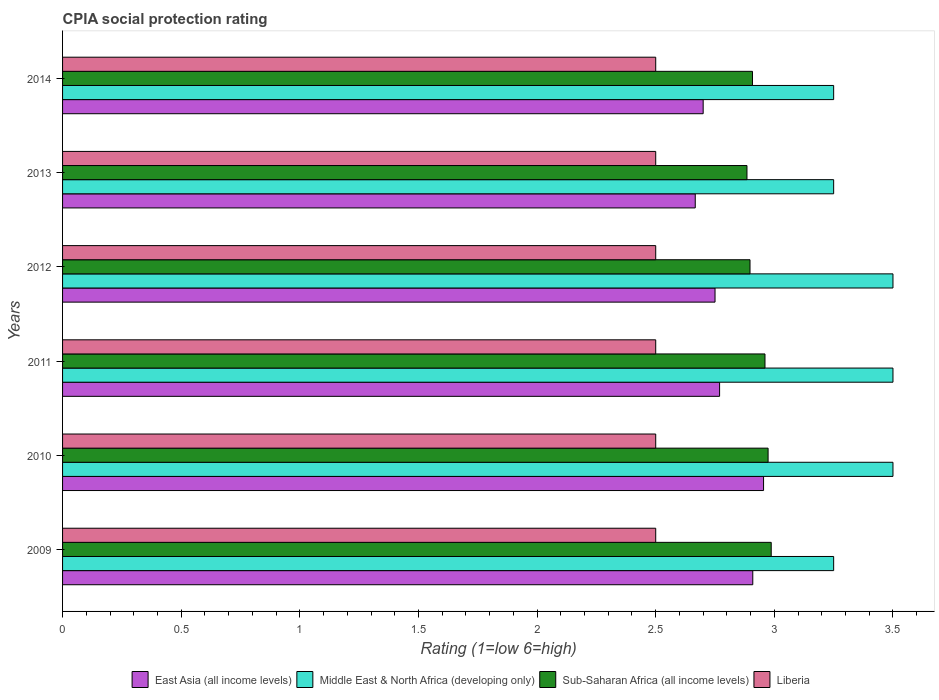How many different coloured bars are there?
Provide a short and direct response. 4. How many groups of bars are there?
Make the answer very short. 6. Are the number of bars on each tick of the Y-axis equal?
Keep it short and to the point. Yes. What is the label of the 1st group of bars from the top?
Offer a terse response. 2014. In how many cases, is the number of bars for a given year not equal to the number of legend labels?
Offer a terse response. 0. What is the CPIA rating in Sub-Saharan Africa (all income levels) in 2013?
Ensure brevity in your answer.  2.88. In which year was the CPIA rating in Middle East & North Africa (developing only) maximum?
Provide a short and direct response. 2010. In which year was the CPIA rating in East Asia (all income levels) minimum?
Your answer should be compact. 2013. What is the total CPIA rating in Sub-Saharan Africa (all income levels) in the graph?
Your response must be concise. 17.61. What is the difference between the CPIA rating in East Asia (all income levels) in 2012 and that in 2013?
Make the answer very short. 0.08. What is the difference between the CPIA rating in Middle East & North Africa (developing only) in 2009 and the CPIA rating in Sub-Saharan Africa (all income levels) in 2013?
Your answer should be very brief. 0.37. What is the average CPIA rating in Sub-Saharan Africa (all income levels) per year?
Provide a short and direct response. 2.94. In the year 2011, what is the difference between the CPIA rating in Liberia and CPIA rating in Sub-Saharan Africa (all income levels)?
Keep it short and to the point. -0.46. In how many years, is the CPIA rating in Liberia greater than 0.8 ?
Make the answer very short. 6. What is the ratio of the CPIA rating in East Asia (all income levels) in 2013 to that in 2014?
Provide a short and direct response. 0.99. What is the difference between the highest and the second highest CPIA rating in Sub-Saharan Africa (all income levels)?
Ensure brevity in your answer.  0.01. What is the difference between the highest and the lowest CPIA rating in East Asia (all income levels)?
Your answer should be compact. 0.29. In how many years, is the CPIA rating in Middle East & North Africa (developing only) greater than the average CPIA rating in Middle East & North Africa (developing only) taken over all years?
Offer a terse response. 3. Is the sum of the CPIA rating in Middle East & North Africa (developing only) in 2010 and 2011 greater than the maximum CPIA rating in East Asia (all income levels) across all years?
Your answer should be compact. Yes. What does the 2nd bar from the top in 2014 represents?
Your response must be concise. Sub-Saharan Africa (all income levels). What does the 1st bar from the bottom in 2012 represents?
Offer a terse response. East Asia (all income levels). Is it the case that in every year, the sum of the CPIA rating in Sub-Saharan Africa (all income levels) and CPIA rating in East Asia (all income levels) is greater than the CPIA rating in Liberia?
Offer a terse response. Yes. How many bars are there?
Keep it short and to the point. 24. How many years are there in the graph?
Keep it short and to the point. 6. What is the difference between two consecutive major ticks on the X-axis?
Give a very brief answer. 0.5. Does the graph contain any zero values?
Offer a terse response. No. Does the graph contain grids?
Keep it short and to the point. No. Where does the legend appear in the graph?
Your answer should be very brief. Bottom center. What is the title of the graph?
Provide a short and direct response. CPIA social protection rating. What is the label or title of the X-axis?
Provide a succinct answer. Rating (1=low 6=high). What is the label or title of the Y-axis?
Provide a short and direct response. Years. What is the Rating (1=low 6=high) in East Asia (all income levels) in 2009?
Your answer should be compact. 2.91. What is the Rating (1=low 6=high) of Middle East & North Africa (developing only) in 2009?
Offer a terse response. 3.25. What is the Rating (1=low 6=high) of Sub-Saharan Africa (all income levels) in 2009?
Give a very brief answer. 2.99. What is the Rating (1=low 6=high) in East Asia (all income levels) in 2010?
Ensure brevity in your answer.  2.95. What is the Rating (1=low 6=high) of Sub-Saharan Africa (all income levels) in 2010?
Provide a short and direct response. 2.97. What is the Rating (1=low 6=high) of East Asia (all income levels) in 2011?
Offer a very short reply. 2.77. What is the Rating (1=low 6=high) in Sub-Saharan Africa (all income levels) in 2011?
Keep it short and to the point. 2.96. What is the Rating (1=low 6=high) of East Asia (all income levels) in 2012?
Provide a succinct answer. 2.75. What is the Rating (1=low 6=high) in Middle East & North Africa (developing only) in 2012?
Your answer should be compact. 3.5. What is the Rating (1=low 6=high) in Sub-Saharan Africa (all income levels) in 2012?
Provide a succinct answer. 2.9. What is the Rating (1=low 6=high) of Liberia in 2012?
Offer a terse response. 2.5. What is the Rating (1=low 6=high) of East Asia (all income levels) in 2013?
Provide a succinct answer. 2.67. What is the Rating (1=low 6=high) of Sub-Saharan Africa (all income levels) in 2013?
Ensure brevity in your answer.  2.88. What is the Rating (1=low 6=high) in Sub-Saharan Africa (all income levels) in 2014?
Make the answer very short. 2.91. What is the Rating (1=low 6=high) of Liberia in 2014?
Offer a very short reply. 2.5. Across all years, what is the maximum Rating (1=low 6=high) of East Asia (all income levels)?
Ensure brevity in your answer.  2.95. Across all years, what is the maximum Rating (1=low 6=high) of Middle East & North Africa (developing only)?
Give a very brief answer. 3.5. Across all years, what is the maximum Rating (1=low 6=high) in Sub-Saharan Africa (all income levels)?
Offer a terse response. 2.99. Across all years, what is the maximum Rating (1=low 6=high) of Liberia?
Provide a short and direct response. 2.5. Across all years, what is the minimum Rating (1=low 6=high) of East Asia (all income levels)?
Provide a short and direct response. 2.67. Across all years, what is the minimum Rating (1=low 6=high) of Sub-Saharan Africa (all income levels)?
Your answer should be compact. 2.88. Across all years, what is the minimum Rating (1=low 6=high) of Liberia?
Provide a short and direct response. 2.5. What is the total Rating (1=low 6=high) of East Asia (all income levels) in the graph?
Your answer should be very brief. 16.75. What is the total Rating (1=low 6=high) of Middle East & North Africa (developing only) in the graph?
Give a very brief answer. 20.25. What is the total Rating (1=low 6=high) in Sub-Saharan Africa (all income levels) in the graph?
Your answer should be very brief. 17.61. What is the total Rating (1=low 6=high) in Liberia in the graph?
Offer a terse response. 15. What is the difference between the Rating (1=low 6=high) in East Asia (all income levels) in 2009 and that in 2010?
Make the answer very short. -0.05. What is the difference between the Rating (1=low 6=high) in Middle East & North Africa (developing only) in 2009 and that in 2010?
Provide a succinct answer. -0.25. What is the difference between the Rating (1=low 6=high) of Sub-Saharan Africa (all income levels) in 2009 and that in 2010?
Provide a succinct answer. 0.01. What is the difference between the Rating (1=low 6=high) in Liberia in 2009 and that in 2010?
Keep it short and to the point. 0. What is the difference between the Rating (1=low 6=high) in East Asia (all income levels) in 2009 and that in 2011?
Offer a terse response. 0.14. What is the difference between the Rating (1=low 6=high) of Middle East & North Africa (developing only) in 2009 and that in 2011?
Your answer should be compact. -0.25. What is the difference between the Rating (1=low 6=high) of Sub-Saharan Africa (all income levels) in 2009 and that in 2011?
Provide a short and direct response. 0.03. What is the difference between the Rating (1=low 6=high) of Liberia in 2009 and that in 2011?
Give a very brief answer. 0. What is the difference between the Rating (1=low 6=high) of East Asia (all income levels) in 2009 and that in 2012?
Provide a short and direct response. 0.16. What is the difference between the Rating (1=low 6=high) in Middle East & North Africa (developing only) in 2009 and that in 2012?
Keep it short and to the point. -0.25. What is the difference between the Rating (1=low 6=high) in Sub-Saharan Africa (all income levels) in 2009 and that in 2012?
Keep it short and to the point. 0.09. What is the difference between the Rating (1=low 6=high) in East Asia (all income levels) in 2009 and that in 2013?
Keep it short and to the point. 0.24. What is the difference between the Rating (1=low 6=high) of Sub-Saharan Africa (all income levels) in 2009 and that in 2013?
Offer a very short reply. 0.1. What is the difference between the Rating (1=low 6=high) of Liberia in 2009 and that in 2013?
Provide a succinct answer. 0. What is the difference between the Rating (1=low 6=high) of East Asia (all income levels) in 2009 and that in 2014?
Provide a short and direct response. 0.21. What is the difference between the Rating (1=low 6=high) of Sub-Saharan Africa (all income levels) in 2009 and that in 2014?
Your answer should be very brief. 0.08. What is the difference between the Rating (1=low 6=high) of East Asia (all income levels) in 2010 and that in 2011?
Your answer should be very brief. 0.19. What is the difference between the Rating (1=low 6=high) of Middle East & North Africa (developing only) in 2010 and that in 2011?
Ensure brevity in your answer.  0. What is the difference between the Rating (1=low 6=high) of Sub-Saharan Africa (all income levels) in 2010 and that in 2011?
Give a very brief answer. 0.01. What is the difference between the Rating (1=low 6=high) of East Asia (all income levels) in 2010 and that in 2012?
Make the answer very short. 0.2. What is the difference between the Rating (1=low 6=high) of Middle East & North Africa (developing only) in 2010 and that in 2012?
Keep it short and to the point. 0. What is the difference between the Rating (1=low 6=high) in Sub-Saharan Africa (all income levels) in 2010 and that in 2012?
Keep it short and to the point. 0.08. What is the difference between the Rating (1=low 6=high) of East Asia (all income levels) in 2010 and that in 2013?
Give a very brief answer. 0.29. What is the difference between the Rating (1=low 6=high) of Sub-Saharan Africa (all income levels) in 2010 and that in 2013?
Your answer should be compact. 0.09. What is the difference between the Rating (1=low 6=high) of East Asia (all income levels) in 2010 and that in 2014?
Offer a terse response. 0.25. What is the difference between the Rating (1=low 6=high) of Middle East & North Africa (developing only) in 2010 and that in 2014?
Your answer should be very brief. 0.25. What is the difference between the Rating (1=low 6=high) of Sub-Saharan Africa (all income levels) in 2010 and that in 2014?
Make the answer very short. 0.07. What is the difference between the Rating (1=low 6=high) of Liberia in 2010 and that in 2014?
Provide a succinct answer. 0. What is the difference between the Rating (1=low 6=high) of East Asia (all income levels) in 2011 and that in 2012?
Your answer should be compact. 0.02. What is the difference between the Rating (1=low 6=high) of Sub-Saharan Africa (all income levels) in 2011 and that in 2012?
Keep it short and to the point. 0.06. What is the difference between the Rating (1=low 6=high) of Liberia in 2011 and that in 2012?
Your answer should be very brief. 0. What is the difference between the Rating (1=low 6=high) of East Asia (all income levels) in 2011 and that in 2013?
Your response must be concise. 0.1. What is the difference between the Rating (1=low 6=high) of Middle East & North Africa (developing only) in 2011 and that in 2013?
Make the answer very short. 0.25. What is the difference between the Rating (1=low 6=high) of Sub-Saharan Africa (all income levels) in 2011 and that in 2013?
Ensure brevity in your answer.  0.08. What is the difference between the Rating (1=low 6=high) in Liberia in 2011 and that in 2013?
Offer a very short reply. 0. What is the difference between the Rating (1=low 6=high) in East Asia (all income levels) in 2011 and that in 2014?
Offer a terse response. 0.07. What is the difference between the Rating (1=low 6=high) in Middle East & North Africa (developing only) in 2011 and that in 2014?
Keep it short and to the point. 0.25. What is the difference between the Rating (1=low 6=high) of Sub-Saharan Africa (all income levels) in 2011 and that in 2014?
Offer a very short reply. 0.05. What is the difference between the Rating (1=low 6=high) of East Asia (all income levels) in 2012 and that in 2013?
Provide a succinct answer. 0.08. What is the difference between the Rating (1=low 6=high) in Middle East & North Africa (developing only) in 2012 and that in 2013?
Your response must be concise. 0.25. What is the difference between the Rating (1=low 6=high) in Sub-Saharan Africa (all income levels) in 2012 and that in 2013?
Offer a very short reply. 0.01. What is the difference between the Rating (1=low 6=high) in Liberia in 2012 and that in 2013?
Your answer should be very brief. 0. What is the difference between the Rating (1=low 6=high) in Sub-Saharan Africa (all income levels) in 2012 and that in 2014?
Offer a very short reply. -0.01. What is the difference between the Rating (1=low 6=high) in Liberia in 2012 and that in 2014?
Give a very brief answer. 0. What is the difference between the Rating (1=low 6=high) of East Asia (all income levels) in 2013 and that in 2014?
Your response must be concise. -0.03. What is the difference between the Rating (1=low 6=high) of Middle East & North Africa (developing only) in 2013 and that in 2014?
Give a very brief answer. 0. What is the difference between the Rating (1=low 6=high) in Sub-Saharan Africa (all income levels) in 2013 and that in 2014?
Provide a short and direct response. -0.02. What is the difference between the Rating (1=low 6=high) in Liberia in 2013 and that in 2014?
Your response must be concise. 0. What is the difference between the Rating (1=low 6=high) in East Asia (all income levels) in 2009 and the Rating (1=low 6=high) in Middle East & North Africa (developing only) in 2010?
Your answer should be compact. -0.59. What is the difference between the Rating (1=low 6=high) in East Asia (all income levels) in 2009 and the Rating (1=low 6=high) in Sub-Saharan Africa (all income levels) in 2010?
Provide a short and direct response. -0.06. What is the difference between the Rating (1=low 6=high) of East Asia (all income levels) in 2009 and the Rating (1=low 6=high) of Liberia in 2010?
Your answer should be very brief. 0.41. What is the difference between the Rating (1=low 6=high) of Middle East & North Africa (developing only) in 2009 and the Rating (1=low 6=high) of Sub-Saharan Africa (all income levels) in 2010?
Your answer should be compact. 0.28. What is the difference between the Rating (1=low 6=high) in Middle East & North Africa (developing only) in 2009 and the Rating (1=low 6=high) in Liberia in 2010?
Keep it short and to the point. 0.75. What is the difference between the Rating (1=low 6=high) in Sub-Saharan Africa (all income levels) in 2009 and the Rating (1=low 6=high) in Liberia in 2010?
Your answer should be compact. 0.49. What is the difference between the Rating (1=low 6=high) in East Asia (all income levels) in 2009 and the Rating (1=low 6=high) in Middle East & North Africa (developing only) in 2011?
Provide a succinct answer. -0.59. What is the difference between the Rating (1=low 6=high) in East Asia (all income levels) in 2009 and the Rating (1=low 6=high) in Sub-Saharan Africa (all income levels) in 2011?
Ensure brevity in your answer.  -0.05. What is the difference between the Rating (1=low 6=high) of East Asia (all income levels) in 2009 and the Rating (1=low 6=high) of Liberia in 2011?
Give a very brief answer. 0.41. What is the difference between the Rating (1=low 6=high) of Middle East & North Africa (developing only) in 2009 and the Rating (1=low 6=high) of Sub-Saharan Africa (all income levels) in 2011?
Offer a terse response. 0.29. What is the difference between the Rating (1=low 6=high) in Middle East & North Africa (developing only) in 2009 and the Rating (1=low 6=high) in Liberia in 2011?
Provide a short and direct response. 0.75. What is the difference between the Rating (1=low 6=high) in Sub-Saharan Africa (all income levels) in 2009 and the Rating (1=low 6=high) in Liberia in 2011?
Ensure brevity in your answer.  0.49. What is the difference between the Rating (1=low 6=high) in East Asia (all income levels) in 2009 and the Rating (1=low 6=high) in Middle East & North Africa (developing only) in 2012?
Provide a short and direct response. -0.59. What is the difference between the Rating (1=low 6=high) of East Asia (all income levels) in 2009 and the Rating (1=low 6=high) of Sub-Saharan Africa (all income levels) in 2012?
Make the answer very short. 0.01. What is the difference between the Rating (1=low 6=high) of East Asia (all income levels) in 2009 and the Rating (1=low 6=high) of Liberia in 2012?
Make the answer very short. 0.41. What is the difference between the Rating (1=low 6=high) of Middle East & North Africa (developing only) in 2009 and the Rating (1=low 6=high) of Sub-Saharan Africa (all income levels) in 2012?
Give a very brief answer. 0.35. What is the difference between the Rating (1=low 6=high) in Middle East & North Africa (developing only) in 2009 and the Rating (1=low 6=high) in Liberia in 2012?
Provide a short and direct response. 0.75. What is the difference between the Rating (1=low 6=high) in Sub-Saharan Africa (all income levels) in 2009 and the Rating (1=low 6=high) in Liberia in 2012?
Make the answer very short. 0.49. What is the difference between the Rating (1=low 6=high) in East Asia (all income levels) in 2009 and the Rating (1=low 6=high) in Middle East & North Africa (developing only) in 2013?
Offer a terse response. -0.34. What is the difference between the Rating (1=low 6=high) in East Asia (all income levels) in 2009 and the Rating (1=low 6=high) in Sub-Saharan Africa (all income levels) in 2013?
Ensure brevity in your answer.  0.02. What is the difference between the Rating (1=low 6=high) in East Asia (all income levels) in 2009 and the Rating (1=low 6=high) in Liberia in 2013?
Provide a succinct answer. 0.41. What is the difference between the Rating (1=low 6=high) of Middle East & North Africa (developing only) in 2009 and the Rating (1=low 6=high) of Sub-Saharan Africa (all income levels) in 2013?
Offer a very short reply. 0.37. What is the difference between the Rating (1=low 6=high) of Middle East & North Africa (developing only) in 2009 and the Rating (1=low 6=high) of Liberia in 2013?
Keep it short and to the point. 0.75. What is the difference between the Rating (1=low 6=high) in Sub-Saharan Africa (all income levels) in 2009 and the Rating (1=low 6=high) in Liberia in 2013?
Ensure brevity in your answer.  0.49. What is the difference between the Rating (1=low 6=high) in East Asia (all income levels) in 2009 and the Rating (1=low 6=high) in Middle East & North Africa (developing only) in 2014?
Offer a terse response. -0.34. What is the difference between the Rating (1=low 6=high) in East Asia (all income levels) in 2009 and the Rating (1=low 6=high) in Sub-Saharan Africa (all income levels) in 2014?
Offer a very short reply. 0. What is the difference between the Rating (1=low 6=high) of East Asia (all income levels) in 2009 and the Rating (1=low 6=high) of Liberia in 2014?
Provide a succinct answer. 0.41. What is the difference between the Rating (1=low 6=high) of Middle East & North Africa (developing only) in 2009 and the Rating (1=low 6=high) of Sub-Saharan Africa (all income levels) in 2014?
Your answer should be very brief. 0.34. What is the difference between the Rating (1=low 6=high) of Sub-Saharan Africa (all income levels) in 2009 and the Rating (1=low 6=high) of Liberia in 2014?
Keep it short and to the point. 0.49. What is the difference between the Rating (1=low 6=high) of East Asia (all income levels) in 2010 and the Rating (1=low 6=high) of Middle East & North Africa (developing only) in 2011?
Give a very brief answer. -0.55. What is the difference between the Rating (1=low 6=high) in East Asia (all income levels) in 2010 and the Rating (1=low 6=high) in Sub-Saharan Africa (all income levels) in 2011?
Make the answer very short. -0.01. What is the difference between the Rating (1=low 6=high) of East Asia (all income levels) in 2010 and the Rating (1=low 6=high) of Liberia in 2011?
Provide a short and direct response. 0.45. What is the difference between the Rating (1=low 6=high) of Middle East & North Africa (developing only) in 2010 and the Rating (1=low 6=high) of Sub-Saharan Africa (all income levels) in 2011?
Keep it short and to the point. 0.54. What is the difference between the Rating (1=low 6=high) in Middle East & North Africa (developing only) in 2010 and the Rating (1=low 6=high) in Liberia in 2011?
Ensure brevity in your answer.  1. What is the difference between the Rating (1=low 6=high) in Sub-Saharan Africa (all income levels) in 2010 and the Rating (1=low 6=high) in Liberia in 2011?
Keep it short and to the point. 0.47. What is the difference between the Rating (1=low 6=high) in East Asia (all income levels) in 2010 and the Rating (1=low 6=high) in Middle East & North Africa (developing only) in 2012?
Keep it short and to the point. -0.55. What is the difference between the Rating (1=low 6=high) in East Asia (all income levels) in 2010 and the Rating (1=low 6=high) in Sub-Saharan Africa (all income levels) in 2012?
Your answer should be compact. 0.06. What is the difference between the Rating (1=low 6=high) of East Asia (all income levels) in 2010 and the Rating (1=low 6=high) of Liberia in 2012?
Provide a succinct answer. 0.45. What is the difference between the Rating (1=low 6=high) in Middle East & North Africa (developing only) in 2010 and the Rating (1=low 6=high) in Sub-Saharan Africa (all income levels) in 2012?
Your response must be concise. 0.6. What is the difference between the Rating (1=low 6=high) in Sub-Saharan Africa (all income levels) in 2010 and the Rating (1=low 6=high) in Liberia in 2012?
Offer a terse response. 0.47. What is the difference between the Rating (1=low 6=high) in East Asia (all income levels) in 2010 and the Rating (1=low 6=high) in Middle East & North Africa (developing only) in 2013?
Keep it short and to the point. -0.3. What is the difference between the Rating (1=low 6=high) of East Asia (all income levels) in 2010 and the Rating (1=low 6=high) of Sub-Saharan Africa (all income levels) in 2013?
Your answer should be compact. 0.07. What is the difference between the Rating (1=low 6=high) of East Asia (all income levels) in 2010 and the Rating (1=low 6=high) of Liberia in 2013?
Offer a terse response. 0.45. What is the difference between the Rating (1=low 6=high) in Middle East & North Africa (developing only) in 2010 and the Rating (1=low 6=high) in Sub-Saharan Africa (all income levels) in 2013?
Keep it short and to the point. 0.62. What is the difference between the Rating (1=low 6=high) in Middle East & North Africa (developing only) in 2010 and the Rating (1=low 6=high) in Liberia in 2013?
Provide a short and direct response. 1. What is the difference between the Rating (1=low 6=high) of Sub-Saharan Africa (all income levels) in 2010 and the Rating (1=low 6=high) of Liberia in 2013?
Offer a very short reply. 0.47. What is the difference between the Rating (1=low 6=high) in East Asia (all income levels) in 2010 and the Rating (1=low 6=high) in Middle East & North Africa (developing only) in 2014?
Offer a very short reply. -0.3. What is the difference between the Rating (1=low 6=high) in East Asia (all income levels) in 2010 and the Rating (1=low 6=high) in Sub-Saharan Africa (all income levels) in 2014?
Offer a terse response. 0.05. What is the difference between the Rating (1=low 6=high) in East Asia (all income levels) in 2010 and the Rating (1=low 6=high) in Liberia in 2014?
Offer a terse response. 0.45. What is the difference between the Rating (1=low 6=high) in Middle East & North Africa (developing only) in 2010 and the Rating (1=low 6=high) in Sub-Saharan Africa (all income levels) in 2014?
Make the answer very short. 0.59. What is the difference between the Rating (1=low 6=high) in Middle East & North Africa (developing only) in 2010 and the Rating (1=low 6=high) in Liberia in 2014?
Your answer should be very brief. 1. What is the difference between the Rating (1=low 6=high) in Sub-Saharan Africa (all income levels) in 2010 and the Rating (1=low 6=high) in Liberia in 2014?
Your response must be concise. 0.47. What is the difference between the Rating (1=low 6=high) in East Asia (all income levels) in 2011 and the Rating (1=low 6=high) in Middle East & North Africa (developing only) in 2012?
Ensure brevity in your answer.  -0.73. What is the difference between the Rating (1=low 6=high) in East Asia (all income levels) in 2011 and the Rating (1=low 6=high) in Sub-Saharan Africa (all income levels) in 2012?
Provide a short and direct response. -0.13. What is the difference between the Rating (1=low 6=high) of East Asia (all income levels) in 2011 and the Rating (1=low 6=high) of Liberia in 2012?
Your answer should be compact. 0.27. What is the difference between the Rating (1=low 6=high) in Middle East & North Africa (developing only) in 2011 and the Rating (1=low 6=high) in Sub-Saharan Africa (all income levels) in 2012?
Ensure brevity in your answer.  0.6. What is the difference between the Rating (1=low 6=high) in Middle East & North Africa (developing only) in 2011 and the Rating (1=low 6=high) in Liberia in 2012?
Your answer should be very brief. 1. What is the difference between the Rating (1=low 6=high) of Sub-Saharan Africa (all income levels) in 2011 and the Rating (1=low 6=high) of Liberia in 2012?
Ensure brevity in your answer.  0.46. What is the difference between the Rating (1=low 6=high) in East Asia (all income levels) in 2011 and the Rating (1=low 6=high) in Middle East & North Africa (developing only) in 2013?
Provide a short and direct response. -0.48. What is the difference between the Rating (1=low 6=high) of East Asia (all income levels) in 2011 and the Rating (1=low 6=high) of Sub-Saharan Africa (all income levels) in 2013?
Your answer should be compact. -0.12. What is the difference between the Rating (1=low 6=high) of East Asia (all income levels) in 2011 and the Rating (1=low 6=high) of Liberia in 2013?
Provide a succinct answer. 0.27. What is the difference between the Rating (1=low 6=high) in Middle East & North Africa (developing only) in 2011 and the Rating (1=low 6=high) in Sub-Saharan Africa (all income levels) in 2013?
Your answer should be compact. 0.62. What is the difference between the Rating (1=low 6=high) of Sub-Saharan Africa (all income levels) in 2011 and the Rating (1=low 6=high) of Liberia in 2013?
Offer a terse response. 0.46. What is the difference between the Rating (1=low 6=high) in East Asia (all income levels) in 2011 and the Rating (1=low 6=high) in Middle East & North Africa (developing only) in 2014?
Offer a very short reply. -0.48. What is the difference between the Rating (1=low 6=high) of East Asia (all income levels) in 2011 and the Rating (1=low 6=high) of Sub-Saharan Africa (all income levels) in 2014?
Your response must be concise. -0.14. What is the difference between the Rating (1=low 6=high) of East Asia (all income levels) in 2011 and the Rating (1=low 6=high) of Liberia in 2014?
Provide a succinct answer. 0.27. What is the difference between the Rating (1=low 6=high) in Middle East & North Africa (developing only) in 2011 and the Rating (1=low 6=high) in Sub-Saharan Africa (all income levels) in 2014?
Your response must be concise. 0.59. What is the difference between the Rating (1=low 6=high) of Sub-Saharan Africa (all income levels) in 2011 and the Rating (1=low 6=high) of Liberia in 2014?
Your response must be concise. 0.46. What is the difference between the Rating (1=low 6=high) of East Asia (all income levels) in 2012 and the Rating (1=low 6=high) of Sub-Saharan Africa (all income levels) in 2013?
Ensure brevity in your answer.  -0.13. What is the difference between the Rating (1=low 6=high) in East Asia (all income levels) in 2012 and the Rating (1=low 6=high) in Liberia in 2013?
Keep it short and to the point. 0.25. What is the difference between the Rating (1=low 6=high) in Middle East & North Africa (developing only) in 2012 and the Rating (1=low 6=high) in Sub-Saharan Africa (all income levels) in 2013?
Provide a succinct answer. 0.62. What is the difference between the Rating (1=low 6=high) of Middle East & North Africa (developing only) in 2012 and the Rating (1=low 6=high) of Liberia in 2013?
Provide a succinct answer. 1. What is the difference between the Rating (1=low 6=high) in Sub-Saharan Africa (all income levels) in 2012 and the Rating (1=low 6=high) in Liberia in 2013?
Provide a succinct answer. 0.4. What is the difference between the Rating (1=low 6=high) of East Asia (all income levels) in 2012 and the Rating (1=low 6=high) of Sub-Saharan Africa (all income levels) in 2014?
Make the answer very short. -0.16. What is the difference between the Rating (1=low 6=high) of East Asia (all income levels) in 2012 and the Rating (1=low 6=high) of Liberia in 2014?
Keep it short and to the point. 0.25. What is the difference between the Rating (1=low 6=high) of Middle East & North Africa (developing only) in 2012 and the Rating (1=low 6=high) of Sub-Saharan Africa (all income levels) in 2014?
Your answer should be compact. 0.59. What is the difference between the Rating (1=low 6=high) of Sub-Saharan Africa (all income levels) in 2012 and the Rating (1=low 6=high) of Liberia in 2014?
Your response must be concise. 0.4. What is the difference between the Rating (1=low 6=high) of East Asia (all income levels) in 2013 and the Rating (1=low 6=high) of Middle East & North Africa (developing only) in 2014?
Offer a very short reply. -0.58. What is the difference between the Rating (1=low 6=high) of East Asia (all income levels) in 2013 and the Rating (1=low 6=high) of Sub-Saharan Africa (all income levels) in 2014?
Ensure brevity in your answer.  -0.24. What is the difference between the Rating (1=low 6=high) in Middle East & North Africa (developing only) in 2013 and the Rating (1=low 6=high) in Sub-Saharan Africa (all income levels) in 2014?
Keep it short and to the point. 0.34. What is the difference between the Rating (1=low 6=high) in Middle East & North Africa (developing only) in 2013 and the Rating (1=low 6=high) in Liberia in 2014?
Offer a very short reply. 0.75. What is the difference between the Rating (1=low 6=high) of Sub-Saharan Africa (all income levels) in 2013 and the Rating (1=low 6=high) of Liberia in 2014?
Provide a short and direct response. 0.38. What is the average Rating (1=low 6=high) in East Asia (all income levels) per year?
Your response must be concise. 2.79. What is the average Rating (1=low 6=high) of Middle East & North Africa (developing only) per year?
Keep it short and to the point. 3.38. What is the average Rating (1=low 6=high) in Sub-Saharan Africa (all income levels) per year?
Give a very brief answer. 2.94. In the year 2009, what is the difference between the Rating (1=low 6=high) in East Asia (all income levels) and Rating (1=low 6=high) in Middle East & North Africa (developing only)?
Offer a terse response. -0.34. In the year 2009, what is the difference between the Rating (1=low 6=high) of East Asia (all income levels) and Rating (1=low 6=high) of Sub-Saharan Africa (all income levels)?
Your response must be concise. -0.08. In the year 2009, what is the difference between the Rating (1=low 6=high) of East Asia (all income levels) and Rating (1=low 6=high) of Liberia?
Keep it short and to the point. 0.41. In the year 2009, what is the difference between the Rating (1=low 6=high) in Middle East & North Africa (developing only) and Rating (1=low 6=high) in Sub-Saharan Africa (all income levels)?
Provide a succinct answer. 0.26. In the year 2009, what is the difference between the Rating (1=low 6=high) of Middle East & North Africa (developing only) and Rating (1=low 6=high) of Liberia?
Provide a short and direct response. 0.75. In the year 2009, what is the difference between the Rating (1=low 6=high) in Sub-Saharan Africa (all income levels) and Rating (1=low 6=high) in Liberia?
Offer a very short reply. 0.49. In the year 2010, what is the difference between the Rating (1=low 6=high) in East Asia (all income levels) and Rating (1=low 6=high) in Middle East & North Africa (developing only)?
Provide a succinct answer. -0.55. In the year 2010, what is the difference between the Rating (1=low 6=high) in East Asia (all income levels) and Rating (1=low 6=high) in Sub-Saharan Africa (all income levels)?
Offer a terse response. -0.02. In the year 2010, what is the difference between the Rating (1=low 6=high) in East Asia (all income levels) and Rating (1=low 6=high) in Liberia?
Offer a terse response. 0.45. In the year 2010, what is the difference between the Rating (1=low 6=high) in Middle East & North Africa (developing only) and Rating (1=low 6=high) in Sub-Saharan Africa (all income levels)?
Your answer should be very brief. 0.53. In the year 2010, what is the difference between the Rating (1=low 6=high) of Middle East & North Africa (developing only) and Rating (1=low 6=high) of Liberia?
Offer a very short reply. 1. In the year 2010, what is the difference between the Rating (1=low 6=high) in Sub-Saharan Africa (all income levels) and Rating (1=low 6=high) in Liberia?
Keep it short and to the point. 0.47. In the year 2011, what is the difference between the Rating (1=low 6=high) in East Asia (all income levels) and Rating (1=low 6=high) in Middle East & North Africa (developing only)?
Your response must be concise. -0.73. In the year 2011, what is the difference between the Rating (1=low 6=high) in East Asia (all income levels) and Rating (1=low 6=high) in Sub-Saharan Africa (all income levels)?
Give a very brief answer. -0.19. In the year 2011, what is the difference between the Rating (1=low 6=high) in East Asia (all income levels) and Rating (1=low 6=high) in Liberia?
Your answer should be very brief. 0.27. In the year 2011, what is the difference between the Rating (1=low 6=high) in Middle East & North Africa (developing only) and Rating (1=low 6=high) in Sub-Saharan Africa (all income levels)?
Offer a terse response. 0.54. In the year 2011, what is the difference between the Rating (1=low 6=high) of Sub-Saharan Africa (all income levels) and Rating (1=low 6=high) of Liberia?
Provide a succinct answer. 0.46. In the year 2012, what is the difference between the Rating (1=low 6=high) in East Asia (all income levels) and Rating (1=low 6=high) in Middle East & North Africa (developing only)?
Provide a short and direct response. -0.75. In the year 2012, what is the difference between the Rating (1=low 6=high) of East Asia (all income levels) and Rating (1=low 6=high) of Sub-Saharan Africa (all income levels)?
Your answer should be compact. -0.15. In the year 2012, what is the difference between the Rating (1=low 6=high) of East Asia (all income levels) and Rating (1=low 6=high) of Liberia?
Give a very brief answer. 0.25. In the year 2012, what is the difference between the Rating (1=low 6=high) of Middle East & North Africa (developing only) and Rating (1=low 6=high) of Sub-Saharan Africa (all income levels)?
Provide a succinct answer. 0.6. In the year 2012, what is the difference between the Rating (1=low 6=high) of Middle East & North Africa (developing only) and Rating (1=low 6=high) of Liberia?
Your response must be concise. 1. In the year 2012, what is the difference between the Rating (1=low 6=high) of Sub-Saharan Africa (all income levels) and Rating (1=low 6=high) of Liberia?
Offer a terse response. 0.4. In the year 2013, what is the difference between the Rating (1=low 6=high) of East Asia (all income levels) and Rating (1=low 6=high) of Middle East & North Africa (developing only)?
Provide a short and direct response. -0.58. In the year 2013, what is the difference between the Rating (1=low 6=high) in East Asia (all income levels) and Rating (1=low 6=high) in Sub-Saharan Africa (all income levels)?
Ensure brevity in your answer.  -0.22. In the year 2013, what is the difference between the Rating (1=low 6=high) in East Asia (all income levels) and Rating (1=low 6=high) in Liberia?
Give a very brief answer. 0.17. In the year 2013, what is the difference between the Rating (1=low 6=high) of Middle East & North Africa (developing only) and Rating (1=low 6=high) of Sub-Saharan Africa (all income levels)?
Your response must be concise. 0.37. In the year 2013, what is the difference between the Rating (1=low 6=high) of Sub-Saharan Africa (all income levels) and Rating (1=low 6=high) of Liberia?
Ensure brevity in your answer.  0.38. In the year 2014, what is the difference between the Rating (1=low 6=high) of East Asia (all income levels) and Rating (1=low 6=high) of Middle East & North Africa (developing only)?
Your answer should be compact. -0.55. In the year 2014, what is the difference between the Rating (1=low 6=high) of East Asia (all income levels) and Rating (1=low 6=high) of Sub-Saharan Africa (all income levels)?
Your answer should be very brief. -0.21. In the year 2014, what is the difference between the Rating (1=low 6=high) in East Asia (all income levels) and Rating (1=low 6=high) in Liberia?
Offer a very short reply. 0.2. In the year 2014, what is the difference between the Rating (1=low 6=high) in Middle East & North Africa (developing only) and Rating (1=low 6=high) in Sub-Saharan Africa (all income levels)?
Offer a very short reply. 0.34. In the year 2014, what is the difference between the Rating (1=low 6=high) of Middle East & North Africa (developing only) and Rating (1=low 6=high) of Liberia?
Offer a terse response. 0.75. In the year 2014, what is the difference between the Rating (1=low 6=high) of Sub-Saharan Africa (all income levels) and Rating (1=low 6=high) of Liberia?
Provide a succinct answer. 0.41. What is the ratio of the Rating (1=low 6=high) of East Asia (all income levels) in 2009 to that in 2010?
Give a very brief answer. 0.98. What is the ratio of the Rating (1=low 6=high) of East Asia (all income levels) in 2009 to that in 2011?
Give a very brief answer. 1.05. What is the ratio of the Rating (1=low 6=high) in Sub-Saharan Africa (all income levels) in 2009 to that in 2011?
Give a very brief answer. 1.01. What is the ratio of the Rating (1=low 6=high) of Liberia in 2009 to that in 2011?
Make the answer very short. 1. What is the ratio of the Rating (1=low 6=high) in East Asia (all income levels) in 2009 to that in 2012?
Your answer should be compact. 1.06. What is the ratio of the Rating (1=low 6=high) in Sub-Saharan Africa (all income levels) in 2009 to that in 2012?
Offer a terse response. 1.03. What is the ratio of the Rating (1=low 6=high) in Sub-Saharan Africa (all income levels) in 2009 to that in 2013?
Provide a succinct answer. 1.04. What is the ratio of the Rating (1=low 6=high) in Liberia in 2009 to that in 2013?
Offer a very short reply. 1. What is the ratio of the Rating (1=low 6=high) in East Asia (all income levels) in 2009 to that in 2014?
Keep it short and to the point. 1.08. What is the ratio of the Rating (1=low 6=high) of Sub-Saharan Africa (all income levels) in 2009 to that in 2014?
Ensure brevity in your answer.  1.03. What is the ratio of the Rating (1=low 6=high) in Liberia in 2009 to that in 2014?
Your response must be concise. 1. What is the ratio of the Rating (1=low 6=high) in East Asia (all income levels) in 2010 to that in 2011?
Offer a terse response. 1.07. What is the ratio of the Rating (1=low 6=high) of Middle East & North Africa (developing only) in 2010 to that in 2011?
Offer a very short reply. 1. What is the ratio of the Rating (1=low 6=high) in East Asia (all income levels) in 2010 to that in 2012?
Your answer should be very brief. 1.07. What is the ratio of the Rating (1=low 6=high) of Middle East & North Africa (developing only) in 2010 to that in 2012?
Keep it short and to the point. 1. What is the ratio of the Rating (1=low 6=high) of Sub-Saharan Africa (all income levels) in 2010 to that in 2012?
Your answer should be very brief. 1.03. What is the ratio of the Rating (1=low 6=high) of East Asia (all income levels) in 2010 to that in 2013?
Provide a succinct answer. 1.11. What is the ratio of the Rating (1=low 6=high) in Sub-Saharan Africa (all income levels) in 2010 to that in 2013?
Give a very brief answer. 1.03. What is the ratio of the Rating (1=low 6=high) of East Asia (all income levels) in 2010 to that in 2014?
Ensure brevity in your answer.  1.09. What is the ratio of the Rating (1=low 6=high) in Middle East & North Africa (developing only) in 2010 to that in 2014?
Keep it short and to the point. 1.08. What is the ratio of the Rating (1=low 6=high) of Sub-Saharan Africa (all income levels) in 2010 to that in 2014?
Keep it short and to the point. 1.02. What is the ratio of the Rating (1=low 6=high) of Liberia in 2010 to that in 2014?
Provide a short and direct response. 1. What is the ratio of the Rating (1=low 6=high) in Middle East & North Africa (developing only) in 2011 to that in 2012?
Give a very brief answer. 1. What is the ratio of the Rating (1=low 6=high) of Sub-Saharan Africa (all income levels) in 2011 to that in 2012?
Make the answer very short. 1.02. What is the ratio of the Rating (1=low 6=high) in East Asia (all income levels) in 2011 to that in 2013?
Provide a short and direct response. 1.04. What is the ratio of the Rating (1=low 6=high) of Middle East & North Africa (developing only) in 2011 to that in 2013?
Offer a very short reply. 1.08. What is the ratio of the Rating (1=low 6=high) of Sub-Saharan Africa (all income levels) in 2011 to that in 2013?
Make the answer very short. 1.03. What is the ratio of the Rating (1=low 6=high) in East Asia (all income levels) in 2011 to that in 2014?
Your answer should be very brief. 1.03. What is the ratio of the Rating (1=low 6=high) of Sub-Saharan Africa (all income levels) in 2011 to that in 2014?
Make the answer very short. 1.02. What is the ratio of the Rating (1=low 6=high) of East Asia (all income levels) in 2012 to that in 2013?
Give a very brief answer. 1.03. What is the ratio of the Rating (1=low 6=high) of Sub-Saharan Africa (all income levels) in 2012 to that in 2013?
Your answer should be compact. 1. What is the ratio of the Rating (1=low 6=high) in East Asia (all income levels) in 2012 to that in 2014?
Offer a terse response. 1.02. What is the ratio of the Rating (1=low 6=high) in Middle East & North Africa (developing only) in 2013 to that in 2014?
Offer a terse response. 1. What is the ratio of the Rating (1=low 6=high) in Sub-Saharan Africa (all income levels) in 2013 to that in 2014?
Give a very brief answer. 0.99. What is the ratio of the Rating (1=low 6=high) in Liberia in 2013 to that in 2014?
Provide a short and direct response. 1. What is the difference between the highest and the second highest Rating (1=low 6=high) of East Asia (all income levels)?
Your answer should be very brief. 0.05. What is the difference between the highest and the second highest Rating (1=low 6=high) in Middle East & North Africa (developing only)?
Offer a very short reply. 0. What is the difference between the highest and the second highest Rating (1=low 6=high) in Sub-Saharan Africa (all income levels)?
Make the answer very short. 0.01. What is the difference between the highest and the lowest Rating (1=low 6=high) of East Asia (all income levels)?
Offer a very short reply. 0.29. What is the difference between the highest and the lowest Rating (1=low 6=high) of Sub-Saharan Africa (all income levels)?
Provide a short and direct response. 0.1. What is the difference between the highest and the lowest Rating (1=low 6=high) of Liberia?
Your answer should be compact. 0. 